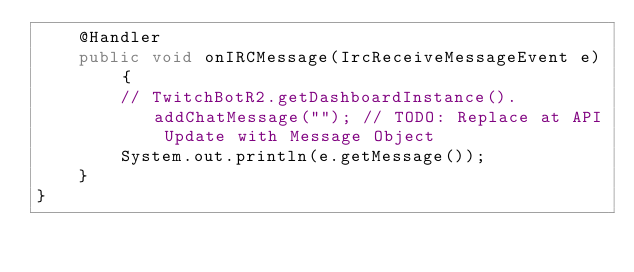<code> <loc_0><loc_0><loc_500><loc_500><_Java_>    @Handler
    public void onIRCMessage(IrcReceiveMessageEvent e) {
        // TwitchBotR2.getDashboardInstance().addChatMessage(""); // TODO: Replace at API Update with Message Object
        System.out.println(e.getMessage());
    }
}
</code> 